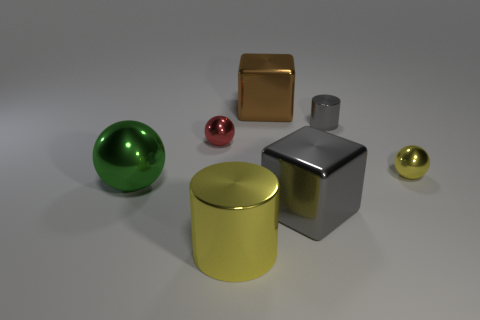Subtract all purple blocks. Subtract all blue cylinders. How many blocks are left? 2 Add 2 green things. How many objects exist? 9 Subtract all spheres. How many objects are left? 4 Add 5 large gray objects. How many large gray objects are left? 6 Add 4 large rubber cubes. How many large rubber cubes exist? 4 Subtract 0 cyan blocks. How many objects are left? 7 Subtract all tiny red spheres. Subtract all metallic balls. How many objects are left? 3 